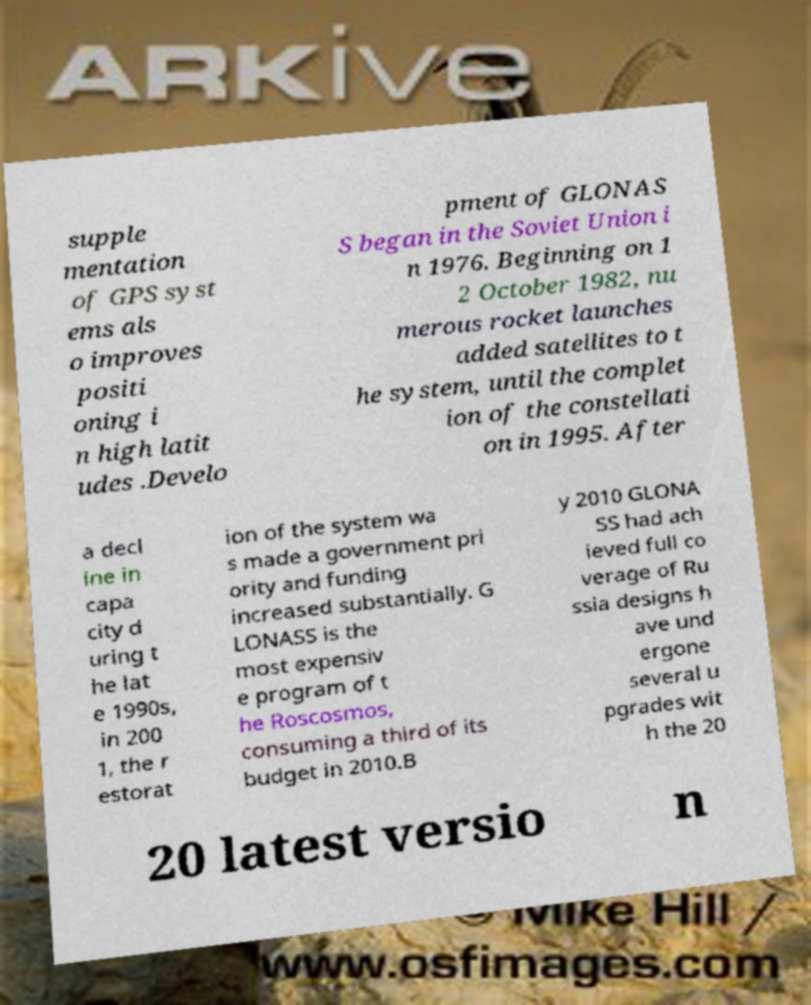I need the written content from this picture converted into text. Can you do that? supple mentation of GPS syst ems als o improves positi oning i n high latit udes .Develo pment of GLONAS S began in the Soviet Union i n 1976. Beginning on 1 2 October 1982, nu merous rocket launches added satellites to t he system, until the complet ion of the constellati on in 1995. After a decl ine in capa city d uring t he lat e 1990s, in 200 1, the r estorat ion of the system wa s made a government pri ority and funding increased substantially. G LONASS is the most expensiv e program of t he Roscosmos, consuming a third of its budget in 2010.B y 2010 GLONA SS had ach ieved full co verage of Ru ssia designs h ave und ergone several u pgrades wit h the 20 20 latest versio n 